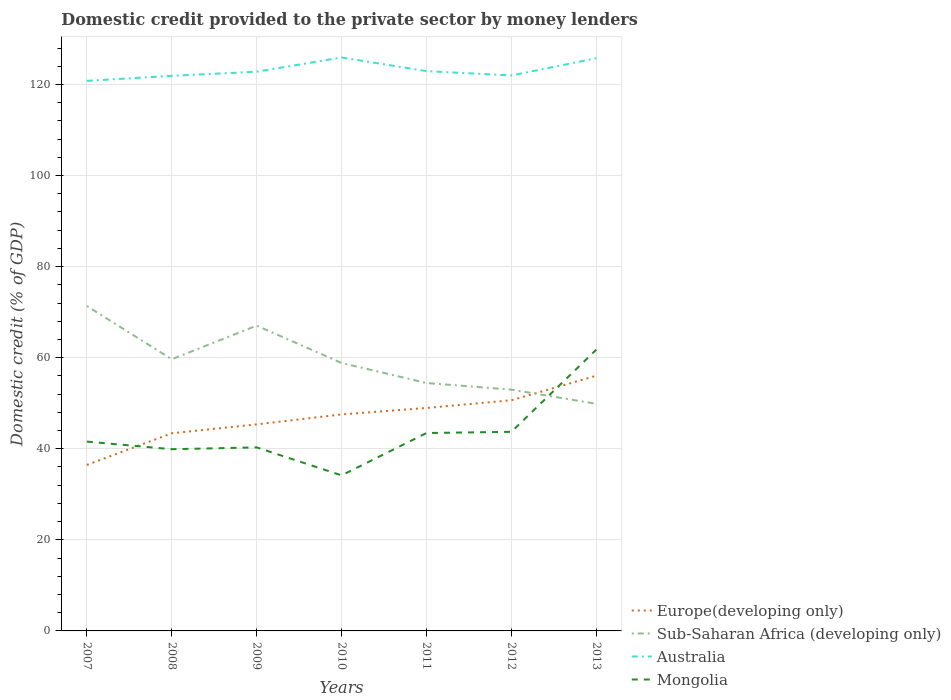Does the line corresponding to Sub-Saharan Africa (developing only) intersect with the line corresponding to Australia?
Your answer should be compact. No. Across all years, what is the maximum domestic credit provided to the private sector by money lenders in Mongolia?
Provide a succinct answer. 34.16. In which year was the domestic credit provided to the private sector by money lenders in Sub-Saharan Africa (developing only) maximum?
Your answer should be compact. 2013. What is the total domestic credit provided to the private sector by money lenders in Sub-Saharan Africa (developing only) in the graph?
Give a very brief answer. 4.31. What is the difference between the highest and the second highest domestic credit provided to the private sector by money lenders in Australia?
Keep it short and to the point. 5.13. Is the domestic credit provided to the private sector by money lenders in Mongolia strictly greater than the domestic credit provided to the private sector by money lenders in Europe(developing only) over the years?
Provide a succinct answer. No. How many years are there in the graph?
Offer a very short reply. 7. Are the values on the major ticks of Y-axis written in scientific E-notation?
Your response must be concise. No. Does the graph contain any zero values?
Provide a succinct answer. No. Does the graph contain grids?
Offer a terse response. Yes. Where does the legend appear in the graph?
Keep it short and to the point. Bottom right. How are the legend labels stacked?
Give a very brief answer. Vertical. What is the title of the graph?
Ensure brevity in your answer.  Domestic credit provided to the private sector by money lenders. Does "Georgia" appear as one of the legend labels in the graph?
Give a very brief answer. No. What is the label or title of the Y-axis?
Your answer should be very brief. Domestic credit (% of GDP). What is the Domestic credit (% of GDP) of Europe(developing only) in 2007?
Make the answer very short. 36.45. What is the Domestic credit (% of GDP) of Sub-Saharan Africa (developing only) in 2007?
Provide a short and direct response. 71.35. What is the Domestic credit (% of GDP) in Australia in 2007?
Your response must be concise. 120.79. What is the Domestic credit (% of GDP) of Mongolia in 2007?
Offer a very short reply. 41.58. What is the Domestic credit (% of GDP) of Europe(developing only) in 2008?
Your answer should be compact. 43.4. What is the Domestic credit (% of GDP) of Sub-Saharan Africa (developing only) in 2008?
Your answer should be very brief. 59.65. What is the Domestic credit (% of GDP) in Australia in 2008?
Provide a short and direct response. 121.89. What is the Domestic credit (% of GDP) of Mongolia in 2008?
Offer a terse response. 39.9. What is the Domestic credit (% of GDP) in Europe(developing only) in 2009?
Your answer should be compact. 45.36. What is the Domestic credit (% of GDP) in Sub-Saharan Africa (developing only) in 2009?
Make the answer very short. 67.04. What is the Domestic credit (% of GDP) in Australia in 2009?
Offer a terse response. 122.8. What is the Domestic credit (% of GDP) of Mongolia in 2009?
Your answer should be compact. 40.3. What is the Domestic credit (% of GDP) in Europe(developing only) in 2010?
Ensure brevity in your answer.  47.54. What is the Domestic credit (% of GDP) in Sub-Saharan Africa (developing only) in 2010?
Give a very brief answer. 58.84. What is the Domestic credit (% of GDP) of Australia in 2010?
Ensure brevity in your answer.  125.92. What is the Domestic credit (% of GDP) of Mongolia in 2010?
Offer a terse response. 34.16. What is the Domestic credit (% of GDP) of Europe(developing only) in 2011?
Give a very brief answer. 48.96. What is the Domestic credit (% of GDP) of Sub-Saharan Africa (developing only) in 2011?
Offer a terse response. 54.44. What is the Domestic credit (% of GDP) of Australia in 2011?
Your answer should be very brief. 122.93. What is the Domestic credit (% of GDP) in Mongolia in 2011?
Provide a succinct answer. 43.46. What is the Domestic credit (% of GDP) in Europe(developing only) in 2012?
Offer a very short reply. 50.66. What is the Domestic credit (% of GDP) of Sub-Saharan Africa (developing only) in 2012?
Provide a short and direct response. 52.98. What is the Domestic credit (% of GDP) in Australia in 2012?
Your answer should be very brief. 121.97. What is the Domestic credit (% of GDP) of Mongolia in 2012?
Keep it short and to the point. 43.72. What is the Domestic credit (% of GDP) of Europe(developing only) in 2013?
Your answer should be compact. 56.04. What is the Domestic credit (% of GDP) in Sub-Saharan Africa (developing only) in 2013?
Provide a short and direct response. 49.87. What is the Domestic credit (% of GDP) in Australia in 2013?
Make the answer very short. 125.76. What is the Domestic credit (% of GDP) of Mongolia in 2013?
Make the answer very short. 61.76. Across all years, what is the maximum Domestic credit (% of GDP) in Europe(developing only)?
Offer a very short reply. 56.04. Across all years, what is the maximum Domestic credit (% of GDP) of Sub-Saharan Africa (developing only)?
Your answer should be very brief. 71.35. Across all years, what is the maximum Domestic credit (% of GDP) of Australia?
Make the answer very short. 125.92. Across all years, what is the maximum Domestic credit (% of GDP) of Mongolia?
Offer a very short reply. 61.76. Across all years, what is the minimum Domestic credit (% of GDP) of Europe(developing only)?
Provide a short and direct response. 36.45. Across all years, what is the minimum Domestic credit (% of GDP) in Sub-Saharan Africa (developing only)?
Give a very brief answer. 49.87. Across all years, what is the minimum Domestic credit (% of GDP) in Australia?
Ensure brevity in your answer.  120.79. Across all years, what is the minimum Domestic credit (% of GDP) of Mongolia?
Provide a succinct answer. 34.16. What is the total Domestic credit (% of GDP) in Europe(developing only) in the graph?
Your answer should be compact. 328.4. What is the total Domestic credit (% of GDP) of Sub-Saharan Africa (developing only) in the graph?
Your response must be concise. 414.17. What is the total Domestic credit (% of GDP) in Australia in the graph?
Ensure brevity in your answer.  862.05. What is the total Domestic credit (% of GDP) in Mongolia in the graph?
Provide a short and direct response. 304.87. What is the difference between the Domestic credit (% of GDP) in Europe(developing only) in 2007 and that in 2008?
Your response must be concise. -6.94. What is the difference between the Domestic credit (% of GDP) in Sub-Saharan Africa (developing only) in 2007 and that in 2008?
Make the answer very short. 11.7. What is the difference between the Domestic credit (% of GDP) in Australia in 2007 and that in 2008?
Your answer should be compact. -1.1. What is the difference between the Domestic credit (% of GDP) of Mongolia in 2007 and that in 2008?
Offer a very short reply. 1.67. What is the difference between the Domestic credit (% of GDP) of Europe(developing only) in 2007 and that in 2009?
Provide a succinct answer. -8.9. What is the difference between the Domestic credit (% of GDP) of Sub-Saharan Africa (developing only) in 2007 and that in 2009?
Keep it short and to the point. 4.31. What is the difference between the Domestic credit (% of GDP) of Australia in 2007 and that in 2009?
Make the answer very short. -2.01. What is the difference between the Domestic credit (% of GDP) of Mongolia in 2007 and that in 2009?
Offer a very short reply. 1.28. What is the difference between the Domestic credit (% of GDP) of Europe(developing only) in 2007 and that in 2010?
Provide a short and direct response. -11.08. What is the difference between the Domestic credit (% of GDP) of Sub-Saharan Africa (developing only) in 2007 and that in 2010?
Your answer should be compact. 12.51. What is the difference between the Domestic credit (% of GDP) of Australia in 2007 and that in 2010?
Offer a terse response. -5.13. What is the difference between the Domestic credit (% of GDP) of Mongolia in 2007 and that in 2010?
Keep it short and to the point. 7.42. What is the difference between the Domestic credit (% of GDP) of Europe(developing only) in 2007 and that in 2011?
Ensure brevity in your answer.  -12.51. What is the difference between the Domestic credit (% of GDP) in Sub-Saharan Africa (developing only) in 2007 and that in 2011?
Make the answer very short. 16.91. What is the difference between the Domestic credit (% of GDP) of Australia in 2007 and that in 2011?
Ensure brevity in your answer.  -2.14. What is the difference between the Domestic credit (% of GDP) of Mongolia in 2007 and that in 2011?
Your answer should be compact. -1.88. What is the difference between the Domestic credit (% of GDP) in Europe(developing only) in 2007 and that in 2012?
Give a very brief answer. -14.2. What is the difference between the Domestic credit (% of GDP) in Sub-Saharan Africa (developing only) in 2007 and that in 2012?
Provide a short and direct response. 18.37. What is the difference between the Domestic credit (% of GDP) of Australia in 2007 and that in 2012?
Your answer should be compact. -1.18. What is the difference between the Domestic credit (% of GDP) of Mongolia in 2007 and that in 2012?
Keep it short and to the point. -2.14. What is the difference between the Domestic credit (% of GDP) in Europe(developing only) in 2007 and that in 2013?
Offer a terse response. -19.58. What is the difference between the Domestic credit (% of GDP) in Sub-Saharan Africa (developing only) in 2007 and that in 2013?
Give a very brief answer. 21.48. What is the difference between the Domestic credit (% of GDP) in Australia in 2007 and that in 2013?
Offer a very short reply. -4.97. What is the difference between the Domestic credit (% of GDP) of Mongolia in 2007 and that in 2013?
Your answer should be very brief. -20.19. What is the difference between the Domestic credit (% of GDP) of Europe(developing only) in 2008 and that in 2009?
Your answer should be very brief. -1.96. What is the difference between the Domestic credit (% of GDP) in Sub-Saharan Africa (developing only) in 2008 and that in 2009?
Keep it short and to the point. -7.39. What is the difference between the Domestic credit (% of GDP) in Australia in 2008 and that in 2009?
Your response must be concise. -0.91. What is the difference between the Domestic credit (% of GDP) in Mongolia in 2008 and that in 2009?
Your response must be concise. -0.4. What is the difference between the Domestic credit (% of GDP) of Europe(developing only) in 2008 and that in 2010?
Give a very brief answer. -4.14. What is the difference between the Domestic credit (% of GDP) of Sub-Saharan Africa (developing only) in 2008 and that in 2010?
Provide a succinct answer. 0.82. What is the difference between the Domestic credit (% of GDP) of Australia in 2008 and that in 2010?
Offer a very short reply. -4.04. What is the difference between the Domestic credit (% of GDP) of Mongolia in 2008 and that in 2010?
Your answer should be very brief. 5.75. What is the difference between the Domestic credit (% of GDP) of Europe(developing only) in 2008 and that in 2011?
Your answer should be very brief. -5.57. What is the difference between the Domestic credit (% of GDP) in Sub-Saharan Africa (developing only) in 2008 and that in 2011?
Make the answer very short. 5.22. What is the difference between the Domestic credit (% of GDP) of Australia in 2008 and that in 2011?
Offer a terse response. -1.04. What is the difference between the Domestic credit (% of GDP) of Mongolia in 2008 and that in 2011?
Provide a short and direct response. -3.56. What is the difference between the Domestic credit (% of GDP) of Europe(developing only) in 2008 and that in 2012?
Ensure brevity in your answer.  -7.26. What is the difference between the Domestic credit (% of GDP) in Sub-Saharan Africa (developing only) in 2008 and that in 2012?
Your answer should be very brief. 6.67. What is the difference between the Domestic credit (% of GDP) of Australia in 2008 and that in 2012?
Provide a short and direct response. -0.08. What is the difference between the Domestic credit (% of GDP) of Mongolia in 2008 and that in 2012?
Provide a short and direct response. -3.82. What is the difference between the Domestic credit (% of GDP) of Europe(developing only) in 2008 and that in 2013?
Offer a very short reply. -12.64. What is the difference between the Domestic credit (% of GDP) in Sub-Saharan Africa (developing only) in 2008 and that in 2013?
Your answer should be very brief. 9.78. What is the difference between the Domestic credit (% of GDP) in Australia in 2008 and that in 2013?
Make the answer very short. -3.87. What is the difference between the Domestic credit (% of GDP) in Mongolia in 2008 and that in 2013?
Provide a succinct answer. -21.86. What is the difference between the Domestic credit (% of GDP) of Europe(developing only) in 2009 and that in 2010?
Provide a short and direct response. -2.18. What is the difference between the Domestic credit (% of GDP) of Sub-Saharan Africa (developing only) in 2009 and that in 2010?
Your answer should be very brief. 8.2. What is the difference between the Domestic credit (% of GDP) in Australia in 2009 and that in 2010?
Make the answer very short. -3.13. What is the difference between the Domestic credit (% of GDP) of Mongolia in 2009 and that in 2010?
Your answer should be very brief. 6.14. What is the difference between the Domestic credit (% of GDP) in Europe(developing only) in 2009 and that in 2011?
Make the answer very short. -3.6. What is the difference between the Domestic credit (% of GDP) of Sub-Saharan Africa (developing only) in 2009 and that in 2011?
Your answer should be very brief. 12.6. What is the difference between the Domestic credit (% of GDP) of Australia in 2009 and that in 2011?
Keep it short and to the point. -0.13. What is the difference between the Domestic credit (% of GDP) in Mongolia in 2009 and that in 2011?
Keep it short and to the point. -3.16. What is the difference between the Domestic credit (% of GDP) of Europe(developing only) in 2009 and that in 2012?
Keep it short and to the point. -5.3. What is the difference between the Domestic credit (% of GDP) in Sub-Saharan Africa (developing only) in 2009 and that in 2012?
Your answer should be compact. 14.06. What is the difference between the Domestic credit (% of GDP) in Australia in 2009 and that in 2012?
Ensure brevity in your answer.  0.83. What is the difference between the Domestic credit (% of GDP) in Mongolia in 2009 and that in 2012?
Make the answer very short. -3.42. What is the difference between the Domestic credit (% of GDP) in Europe(developing only) in 2009 and that in 2013?
Ensure brevity in your answer.  -10.68. What is the difference between the Domestic credit (% of GDP) in Sub-Saharan Africa (developing only) in 2009 and that in 2013?
Make the answer very short. 17.17. What is the difference between the Domestic credit (% of GDP) of Australia in 2009 and that in 2013?
Provide a succinct answer. -2.96. What is the difference between the Domestic credit (% of GDP) in Mongolia in 2009 and that in 2013?
Give a very brief answer. -21.46. What is the difference between the Domestic credit (% of GDP) of Europe(developing only) in 2010 and that in 2011?
Your answer should be very brief. -1.42. What is the difference between the Domestic credit (% of GDP) in Sub-Saharan Africa (developing only) in 2010 and that in 2011?
Keep it short and to the point. 4.4. What is the difference between the Domestic credit (% of GDP) of Australia in 2010 and that in 2011?
Your answer should be very brief. 3. What is the difference between the Domestic credit (% of GDP) in Mongolia in 2010 and that in 2011?
Offer a very short reply. -9.3. What is the difference between the Domestic credit (% of GDP) of Europe(developing only) in 2010 and that in 2012?
Your answer should be very brief. -3.12. What is the difference between the Domestic credit (% of GDP) in Sub-Saharan Africa (developing only) in 2010 and that in 2012?
Your answer should be very brief. 5.86. What is the difference between the Domestic credit (% of GDP) of Australia in 2010 and that in 2012?
Keep it short and to the point. 3.95. What is the difference between the Domestic credit (% of GDP) in Mongolia in 2010 and that in 2012?
Keep it short and to the point. -9.56. What is the difference between the Domestic credit (% of GDP) in Europe(developing only) in 2010 and that in 2013?
Provide a succinct answer. -8.5. What is the difference between the Domestic credit (% of GDP) in Sub-Saharan Africa (developing only) in 2010 and that in 2013?
Your answer should be compact. 8.97. What is the difference between the Domestic credit (% of GDP) of Australia in 2010 and that in 2013?
Offer a terse response. 0.16. What is the difference between the Domestic credit (% of GDP) in Mongolia in 2010 and that in 2013?
Your answer should be compact. -27.61. What is the difference between the Domestic credit (% of GDP) of Europe(developing only) in 2011 and that in 2012?
Provide a short and direct response. -1.69. What is the difference between the Domestic credit (% of GDP) in Sub-Saharan Africa (developing only) in 2011 and that in 2012?
Your response must be concise. 1.46. What is the difference between the Domestic credit (% of GDP) in Australia in 2011 and that in 2012?
Offer a very short reply. 0.96. What is the difference between the Domestic credit (% of GDP) of Mongolia in 2011 and that in 2012?
Provide a succinct answer. -0.26. What is the difference between the Domestic credit (% of GDP) of Europe(developing only) in 2011 and that in 2013?
Ensure brevity in your answer.  -7.08. What is the difference between the Domestic credit (% of GDP) in Sub-Saharan Africa (developing only) in 2011 and that in 2013?
Ensure brevity in your answer.  4.57. What is the difference between the Domestic credit (% of GDP) of Australia in 2011 and that in 2013?
Your answer should be compact. -2.83. What is the difference between the Domestic credit (% of GDP) in Mongolia in 2011 and that in 2013?
Offer a terse response. -18.3. What is the difference between the Domestic credit (% of GDP) in Europe(developing only) in 2012 and that in 2013?
Make the answer very short. -5.38. What is the difference between the Domestic credit (% of GDP) of Sub-Saharan Africa (developing only) in 2012 and that in 2013?
Give a very brief answer. 3.11. What is the difference between the Domestic credit (% of GDP) in Australia in 2012 and that in 2013?
Provide a succinct answer. -3.79. What is the difference between the Domestic credit (% of GDP) of Mongolia in 2012 and that in 2013?
Your response must be concise. -18.05. What is the difference between the Domestic credit (% of GDP) in Europe(developing only) in 2007 and the Domestic credit (% of GDP) in Sub-Saharan Africa (developing only) in 2008?
Your response must be concise. -23.2. What is the difference between the Domestic credit (% of GDP) of Europe(developing only) in 2007 and the Domestic credit (% of GDP) of Australia in 2008?
Give a very brief answer. -85.43. What is the difference between the Domestic credit (% of GDP) of Europe(developing only) in 2007 and the Domestic credit (% of GDP) of Mongolia in 2008?
Your answer should be compact. -3.45. What is the difference between the Domestic credit (% of GDP) in Sub-Saharan Africa (developing only) in 2007 and the Domestic credit (% of GDP) in Australia in 2008?
Give a very brief answer. -50.54. What is the difference between the Domestic credit (% of GDP) of Sub-Saharan Africa (developing only) in 2007 and the Domestic credit (% of GDP) of Mongolia in 2008?
Your answer should be very brief. 31.45. What is the difference between the Domestic credit (% of GDP) of Australia in 2007 and the Domestic credit (% of GDP) of Mongolia in 2008?
Offer a terse response. 80.89. What is the difference between the Domestic credit (% of GDP) of Europe(developing only) in 2007 and the Domestic credit (% of GDP) of Sub-Saharan Africa (developing only) in 2009?
Provide a short and direct response. -30.58. What is the difference between the Domestic credit (% of GDP) of Europe(developing only) in 2007 and the Domestic credit (% of GDP) of Australia in 2009?
Your response must be concise. -86.34. What is the difference between the Domestic credit (% of GDP) of Europe(developing only) in 2007 and the Domestic credit (% of GDP) of Mongolia in 2009?
Give a very brief answer. -3.85. What is the difference between the Domestic credit (% of GDP) in Sub-Saharan Africa (developing only) in 2007 and the Domestic credit (% of GDP) in Australia in 2009?
Your answer should be very brief. -51.45. What is the difference between the Domestic credit (% of GDP) in Sub-Saharan Africa (developing only) in 2007 and the Domestic credit (% of GDP) in Mongolia in 2009?
Your answer should be very brief. 31.05. What is the difference between the Domestic credit (% of GDP) of Australia in 2007 and the Domestic credit (% of GDP) of Mongolia in 2009?
Provide a short and direct response. 80.49. What is the difference between the Domestic credit (% of GDP) in Europe(developing only) in 2007 and the Domestic credit (% of GDP) in Sub-Saharan Africa (developing only) in 2010?
Offer a very short reply. -22.38. What is the difference between the Domestic credit (% of GDP) of Europe(developing only) in 2007 and the Domestic credit (% of GDP) of Australia in 2010?
Give a very brief answer. -89.47. What is the difference between the Domestic credit (% of GDP) of Europe(developing only) in 2007 and the Domestic credit (% of GDP) of Mongolia in 2010?
Give a very brief answer. 2.3. What is the difference between the Domestic credit (% of GDP) of Sub-Saharan Africa (developing only) in 2007 and the Domestic credit (% of GDP) of Australia in 2010?
Keep it short and to the point. -54.57. What is the difference between the Domestic credit (% of GDP) in Sub-Saharan Africa (developing only) in 2007 and the Domestic credit (% of GDP) in Mongolia in 2010?
Give a very brief answer. 37.19. What is the difference between the Domestic credit (% of GDP) of Australia in 2007 and the Domestic credit (% of GDP) of Mongolia in 2010?
Your answer should be compact. 86.63. What is the difference between the Domestic credit (% of GDP) of Europe(developing only) in 2007 and the Domestic credit (% of GDP) of Sub-Saharan Africa (developing only) in 2011?
Offer a terse response. -17.98. What is the difference between the Domestic credit (% of GDP) in Europe(developing only) in 2007 and the Domestic credit (% of GDP) in Australia in 2011?
Your answer should be compact. -86.47. What is the difference between the Domestic credit (% of GDP) of Europe(developing only) in 2007 and the Domestic credit (% of GDP) of Mongolia in 2011?
Make the answer very short. -7. What is the difference between the Domestic credit (% of GDP) in Sub-Saharan Africa (developing only) in 2007 and the Domestic credit (% of GDP) in Australia in 2011?
Give a very brief answer. -51.58. What is the difference between the Domestic credit (% of GDP) in Sub-Saharan Africa (developing only) in 2007 and the Domestic credit (% of GDP) in Mongolia in 2011?
Offer a very short reply. 27.89. What is the difference between the Domestic credit (% of GDP) in Australia in 2007 and the Domestic credit (% of GDP) in Mongolia in 2011?
Keep it short and to the point. 77.33. What is the difference between the Domestic credit (% of GDP) in Europe(developing only) in 2007 and the Domestic credit (% of GDP) in Sub-Saharan Africa (developing only) in 2012?
Provide a succinct answer. -16.52. What is the difference between the Domestic credit (% of GDP) in Europe(developing only) in 2007 and the Domestic credit (% of GDP) in Australia in 2012?
Keep it short and to the point. -85.51. What is the difference between the Domestic credit (% of GDP) in Europe(developing only) in 2007 and the Domestic credit (% of GDP) in Mongolia in 2012?
Your response must be concise. -7.26. What is the difference between the Domestic credit (% of GDP) in Sub-Saharan Africa (developing only) in 2007 and the Domestic credit (% of GDP) in Australia in 2012?
Your response must be concise. -50.62. What is the difference between the Domestic credit (% of GDP) of Sub-Saharan Africa (developing only) in 2007 and the Domestic credit (% of GDP) of Mongolia in 2012?
Give a very brief answer. 27.63. What is the difference between the Domestic credit (% of GDP) of Australia in 2007 and the Domestic credit (% of GDP) of Mongolia in 2012?
Your answer should be compact. 77.07. What is the difference between the Domestic credit (% of GDP) of Europe(developing only) in 2007 and the Domestic credit (% of GDP) of Sub-Saharan Africa (developing only) in 2013?
Provide a succinct answer. -13.42. What is the difference between the Domestic credit (% of GDP) of Europe(developing only) in 2007 and the Domestic credit (% of GDP) of Australia in 2013?
Keep it short and to the point. -89.3. What is the difference between the Domestic credit (% of GDP) in Europe(developing only) in 2007 and the Domestic credit (% of GDP) in Mongolia in 2013?
Ensure brevity in your answer.  -25.31. What is the difference between the Domestic credit (% of GDP) in Sub-Saharan Africa (developing only) in 2007 and the Domestic credit (% of GDP) in Australia in 2013?
Provide a succinct answer. -54.41. What is the difference between the Domestic credit (% of GDP) of Sub-Saharan Africa (developing only) in 2007 and the Domestic credit (% of GDP) of Mongolia in 2013?
Ensure brevity in your answer.  9.59. What is the difference between the Domestic credit (% of GDP) of Australia in 2007 and the Domestic credit (% of GDP) of Mongolia in 2013?
Give a very brief answer. 59.02. What is the difference between the Domestic credit (% of GDP) in Europe(developing only) in 2008 and the Domestic credit (% of GDP) in Sub-Saharan Africa (developing only) in 2009?
Provide a short and direct response. -23.64. What is the difference between the Domestic credit (% of GDP) of Europe(developing only) in 2008 and the Domestic credit (% of GDP) of Australia in 2009?
Keep it short and to the point. -79.4. What is the difference between the Domestic credit (% of GDP) of Europe(developing only) in 2008 and the Domestic credit (% of GDP) of Mongolia in 2009?
Make the answer very short. 3.1. What is the difference between the Domestic credit (% of GDP) in Sub-Saharan Africa (developing only) in 2008 and the Domestic credit (% of GDP) in Australia in 2009?
Ensure brevity in your answer.  -63.14. What is the difference between the Domestic credit (% of GDP) of Sub-Saharan Africa (developing only) in 2008 and the Domestic credit (% of GDP) of Mongolia in 2009?
Offer a terse response. 19.35. What is the difference between the Domestic credit (% of GDP) in Australia in 2008 and the Domestic credit (% of GDP) in Mongolia in 2009?
Your answer should be compact. 81.59. What is the difference between the Domestic credit (% of GDP) in Europe(developing only) in 2008 and the Domestic credit (% of GDP) in Sub-Saharan Africa (developing only) in 2010?
Your response must be concise. -15.44. What is the difference between the Domestic credit (% of GDP) of Europe(developing only) in 2008 and the Domestic credit (% of GDP) of Australia in 2010?
Make the answer very short. -82.53. What is the difference between the Domestic credit (% of GDP) of Europe(developing only) in 2008 and the Domestic credit (% of GDP) of Mongolia in 2010?
Ensure brevity in your answer.  9.24. What is the difference between the Domestic credit (% of GDP) of Sub-Saharan Africa (developing only) in 2008 and the Domestic credit (% of GDP) of Australia in 2010?
Provide a succinct answer. -66.27. What is the difference between the Domestic credit (% of GDP) of Sub-Saharan Africa (developing only) in 2008 and the Domestic credit (% of GDP) of Mongolia in 2010?
Provide a succinct answer. 25.5. What is the difference between the Domestic credit (% of GDP) in Australia in 2008 and the Domestic credit (% of GDP) in Mongolia in 2010?
Your response must be concise. 87.73. What is the difference between the Domestic credit (% of GDP) of Europe(developing only) in 2008 and the Domestic credit (% of GDP) of Sub-Saharan Africa (developing only) in 2011?
Your answer should be very brief. -11.04. What is the difference between the Domestic credit (% of GDP) of Europe(developing only) in 2008 and the Domestic credit (% of GDP) of Australia in 2011?
Provide a succinct answer. -79.53. What is the difference between the Domestic credit (% of GDP) of Europe(developing only) in 2008 and the Domestic credit (% of GDP) of Mongolia in 2011?
Provide a succinct answer. -0.06. What is the difference between the Domestic credit (% of GDP) in Sub-Saharan Africa (developing only) in 2008 and the Domestic credit (% of GDP) in Australia in 2011?
Keep it short and to the point. -63.27. What is the difference between the Domestic credit (% of GDP) of Sub-Saharan Africa (developing only) in 2008 and the Domestic credit (% of GDP) of Mongolia in 2011?
Your answer should be very brief. 16.19. What is the difference between the Domestic credit (% of GDP) of Australia in 2008 and the Domestic credit (% of GDP) of Mongolia in 2011?
Your answer should be very brief. 78.43. What is the difference between the Domestic credit (% of GDP) of Europe(developing only) in 2008 and the Domestic credit (% of GDP) of Sub-Saharan Africa (developing only) in 2012?
Offer a very short reply. -9.58. What is the difference between the Domestic credit (% of GDP) in Europe(developing only) in 2008 and the Domestic credit (% of GDP) in Australia in 2012?
Provide a short and direct response. -78.57. What is the difference between the Domestic credit (% of GDP) in Europe(developing only) in 2008 and the Domestic credit (% of GDP) in Mongolia in 2012?
Offer a terse response. -0.32. What is the difference between the Domestic credit (% of GDP) of Sub-Saharan Africa (developing only) in 2008 and the Domestic credit (% of GDP) of Australia in 2012?
Provide a short and direct response. -62.31. What is the difference between the Domestic credit (% of GDP) of Sub-Saharan Africa (developing only) in 2008 and the Domestic credit (% of GDP) of Mongolia in 2012?
Your answer should be compact. 15.94. What is the difference between the Domestic credit (% of GDP) in Australia in 2008 and the Domestic credit (% of GDP) in Mongolia in 2012?
Your answer should be compact. 78.17. What is the difference between the Domestic credit (% of GDP) in Europe(developing only) in 2008 and the Domestic credit (% of GDP) in Sub-Saharan Africa (developing only) in 2013?
Give a very brief answer. -6.48. What is the difference between the Domestic credit (% of GDP) of Europe(developing only) in 2008 and the Domestic credit (% of GDP) of Australia in 2013?
Make the answer very short. -82.36. What is the difference between the Domestic credit (% of GDP) in Europe(developing only) in 2008 and the Domestic credit (% of GDP) in Mongolia in 2013?
Offer a terse response. -18.37. What is the difference between the Domestic credit (% of GDP) of Sub-Saharan Africa (developing only) in 2008 and the Domestic credit (% of GDP) of Australia in 2013?
Make the answer very short. -66.1. What is the difference between the Domestic credit (% of GDP) in Sub-Saharan Africa (developing only) in 2008 and the Domestic credit (% of GDP) in Mongolia in 2013?
Your response must be concise. -2.11. What is the difference between the Domestic credit (% of GDP) of Australia in 2008 and the Domestic credit (% of GDP) of Mongolia in 2013?
Your response must be concise. 60.12. What is the difference between the Domestic credit (% of GDP) of Europe(developing only) in 2009 and the Domestic credit (% of GDP) of Sub-Saharan Africa (developing only) in 2010?
Offer a terse response. -13.48. What is the difference between the Domestic credit (% of GDP) in Europe(developing only) in 2009 and the Domestic credit (% of GDP) in Australia in 2010?
Offer a very short reply. -80.57. What is the difference between the Domestic credit (% of GDP) of Europe(developing only) in 2009 and the Domestic credit (% of GDP) of Mongolia in 2010?
Make the answer very short. 11.2. What is the difference between the Domestic credit (% of GDP) of Sub-Saharan Africa (developing only) in 2009 and the Domestic credit (% of GDP) of Australia in 2010?
Make the answer very short. -58.88. What is the difference between the Domestic credit (% of GDP) of Sub-Saharan Africa (developing only) in 2009 and the Domestic credit (% of GDP) of Mongolia in 2010?
Offer a very short reply. 32.88. What is the difference between the Domestic credit (% of GDP) of Australia in 2009 and the Domestic credit (% of GDP) of Mongolia in 2010?
Provide a short and direct response. 88.64. What is the difference between the Domestic credit (% of GDP) of Europe(developing only) in 2009 and the Domestic credit (% of GDP) of Sub-Saharan Africa (developing only) in 2011?
Your answer should be very brief. -9.08. What is the difference between the Domestic credit (% of GDP) of Europe(developing only) in 2009 and the Domestic credit (% of GDP) of Australia in 2011?
Offer a terse response. -77.57. What is the difference between the Domestic credit (% of GDP) of Europe(developing only) in 2009 and the Domestic credit (% of GDP) of Mongolia in 2011?
Ensure brevity in your answer.  1.9. What is the difference between the Domestic credit (% of GDP) in Sub-Saharan Africa (developing only) in 2009 and the Domestic credit (% of GDP) in Australia in 2011?
Your answer should be very brief. -55.89. What is the difference between the Domestic credit (% of GDP) of Sub-Saharan Africa (developing only) in 2009 and the Domestic credit (% of GDP) of Mongolia in 2011?
Offer a very short reply. 23.58. What is the difference between the Domestic credit (% of GDP) of Australia in 2009 and the Domestic credit (% of GDP) of Mongolia in 2011?
Provide a short and direct response. 79.34. What is the difference between the Domestic credit (% of GDP) in Europe(developing only) in 2009 and the Domestic credit (% of GDP) in Sub-Saharan Africa (developing only) in 2012?
Your answer should be very brief. -7.62. What is the difference between the Domestic credit (% of GDP) of Europe(developing only) in 2009 and the Domestic credit (% of GDP) of Australia in 2012?
Your answer should be very brief. -76.61. What is the difference between the Domestic credit (% of GDP) in Europe(developing only) in 2009 and the Domestic credit (% of GDP) in Mongolia in 2012?
Your response must be concise. 1.64. What is the difference between the Domestic credit (% of GDP) of Sub-Saharan Africa (developing only) in 2009 and the Domestic credit (% of GDP) of Australia in 2012?
Your response must be concise. -54.93. What is the difference between the Domestic credit (% of GDP) of Sub-Saharan Africa (developing only) in 2009 and the Domestic credit (% of GDP) of Mongolia in 2012?
Provide a succinct answer. 23.32. What is the difference between the Domestic credit (% of GDP) of Australia in 2009 and the Domestic credit (% of GDP) of Mongolia in 2012?
Your answer should be compact. 79.08. What is the difference between the Domestic credit (% of GDP) in Europe(developing only) in 2009 and the Domestic credit (% of GDP) in Sub-Saharan Africa (developing only) in 2013?
Offer a terse response. -4.51. What is the difference between the Domestic credit (% of GDP) in Europe(developing only) in 2009 and the Domestic credit (% of GDP) in Australia in 2013?
Give a very brief answer. -80.4. What is the difference between the Domestic credit (% of GDP) in Europe(developing only) in 2009 and the Domestic credit (% of GDP) in Mongolia in 2013?
Make the answer very short. -16.41. What is the difference between the Domestic credit (% of GDP) in Sub-Saharan Africa (developing only) in 2009 and the Domestic credit (% of GDP) in Australia in 2013?
Offer a very short reply. -58.72. What is the difference between the Domestic credit (% of GDP) in Sub-Saharan Africa (developing only) in 2009 and the Domestic credit (% of GDP) in Mongolia in 2013?
Offer a terse response. 5.28. What is the difference between the Domestic credit (% of GDP) in Australia in 2009 and the Domestic credit (% of GDP) in Mongolia in 2013?
Keep it short and to the point. 61.03. What is the difference between the Domestic credit (% of GDP) in Europe(developing only) in 2010 and the Domestic credit (% of GDP) in Sub-Saharan Africa (developing only) in 2011?
Your answer should be compact. -6.9. What is the difference between the Domestic credit (% of GDP) in Europe(developing only) in 2010 and the Domestic credit (% of GDP) in Australia in 2011?
Your answer should be compact. -75.39. What is the difference between the Domestic credit (% of GDP) of Europe(developing only) in 2010 and the Domestic credit (% of GDP) of Mongolia in 2011?
Your response must be concise. 4.08. What is the difference between the Domestic credit (% of GDP) in Sub-Saharan Africa (developing only) in 2010 and the Domestic credit (% of GDP) in Australia in 2011?
Ensure brevity in your answer.  -64.09. What is the difference between the Domestic credit (% of GDP) in Sub-Saharan Africa (developing only) in 2010 and the Domestic credit (% of GDP) in Mongolia in 2011?
Offer a terse response. 15.38. What is the difference between the Domestic credit (% of GDP) in Australia in 2010 and the Domestic credit (% of GDP) in Mongolia in 2011?
Make the answer very short. 82.46. What is the difference between the Domestic credit (% of GDP) of Europe(developing only) in 2010 and the Domestic credit (% of GDP) of Sub-Saharan Africa (developing only) in 2012?
Keep it short and to the point. -5.44. What is the difference between the Domestic credit (% of GDP) of Europe(developing only) in 2010 and the Domestic credit (% of GDP) of Australia in 2012?
Your response must be concise. -74.43. What is the difference between the Domestic credit (% of GDP) in Europe(developing only) in 2010 and the Domestic credit (% of GDP) in Mongolia in 2012?
Your answer should be very brief. 3.82. What is the difference between the Domestic credit (% of GDP) of Sub-Saharan Africa (developing only) in 2010 and the Domestic credit (% of GDP) of Australia in 2012?
Offer a very short reply. -63.13. What is the difference between the Domestic credit (% of GDP) of Sub-Saharan Africa (developing only) in 2010 and the Domestic credit (% of GDP) of Mongolia in 2012?
Give a very brief answer. 15.12. What is the difference between the Domestic credit (% of GDP) in Australia in 2010 and the Domestic credit (% of GDP) in Mongolia in 2012?
Make the answer very short. 82.21. What is the difference between the Domestic credit (% of GDP) in Europe(developing only) in 2010 and the Domestic credit (% of GDP) in Sub-Saharan Africa (developing only) in 2013?
Make the answer very short. -2.33. What is the difference between the Domestic credit (% of GDP) of Europe(developing only) in 2010 and the Domestic credit (% of GDP) of Australia in 2013?
Your response must be concise. -78.22. What is the difference between the Domestic credit (% of GDP) in Europe(developing only) in 2010 and the Domestic credit (% of GDP) in Mongolia in 2013?
Offer a terse response. -14.23. What is the difference between the Domestic credit (% of GDP) in Sub-Saharan Africa (developing only) in 2010 and the Domestic credit (% of GDP) in Australia in 2013?
Provide a short and direct response. -66.92. What is the difference between the Domestic credit (% of GDP) in Sub-Saharan Africa (developing only) in 2010 and the Domestic credit (% of GDP) in Mongolia in 2013?
Your answer should be compact. -2.93. What is the difference between the Domestic credit (% of GDP) of Australia in 2010 and the Domestic credit (% of GDP) of Mongolia in 2013?
Give a very brief answer. 64.16. What is the difference between the Domestic credit (% of GDP) in Europe(developing only) in 2011 and the Domestic credit (% of GDP) in Sub-Saharan Africa (developing only) in 2012?
Keep it short and to the point. -4.02. What is the difference between the Domestic credit (% of GDP) of Europe(developing only) in 2011 and the Domestic credit (% of GDP) of Australia in 2012?
Give a very brief answer. -73.01. What is the difference between the Domestic credit (% of GDP) of Europe(developing only) in 2011 and the Domestic credit (% of GDP) of Mongolia in 2012?
Keep it short and to the point. 5.25. What is the difference between the Domestic credit (% of GDP) of Sub-Saharan Africa (developing only) in 2011 and the Domestic credit (% of GDP) of Australia in 2012?
Ensure brevity in your answer.  -67.53. What is the difference between the Domestic credit (% of GDP) of Sub-Saharan Africa (developing only) in 2011 and the Domestic credit (% of GDP) of Mongolia in 2012?
Keep it short and to the point. 10.72. What is the difference between the Domestic credit (% of GDP) of Australia in 2011 and the Domestic credit (% of GDP) of Mongolia in 2012?
Make the answer very short. 79.21. What is the difference between the Domestic credit (% of GDP) of Europe(developing only) in 2011 and the Domestic credit (% of GDP) of Sub-Saharan Africa (developing only) in 2013?
Offer a terse response. -0.91. What is the difference between the Domestic credit (% of GDP) in Europe(developing only) in 2011 and the Domestic credit (% of GDP) in Australia in 2013?
Provide a succinct answer. -76.8. What is the difference between the Domestic credit (% of GDP) in Europe(developing only) in 2011 and the Domestic credit (% of GDP) in Mongolia in 2013?
Ensure brevity in your answer.  -12.8. What is the difference between the Domestic credit (% of GDP) of Sub-Saharan Africa (developing only) in 2011 and the Domestic credit (% of GDP) of Australia in 2013?
Your answer should be compact. -71.32. What is the difference between the Domestic credit (% of GDP) of Sub-Saharan Africa (developing only) in 2011 and the Domestic credit (% of GDP) of Mongolia in 2013?
Your answer should be very brief. -7.33. What is the difference between the Domestic credit (% of GDP) of Australia in 2011 and the Domestic credit (% of GDP) of Mongolia in 2013?
Your answer should be very brief. 61.16. What is the difference between the Domestic credit (% of GDP) in Europe(developing only) in 2012 and the Domestic credit (% of GDP) in Sub-Saharan Africa (developing only) in 2013?
Offer a very short reply. 0.78. What is the difference between the Domestic credit (% of GDP) in Europe(developing only) in 2012 and the Domestic credit (% of GDP) in Australia in 2013?
Provide a succinct answer. -75.1. What is the difference between the Domestic credit (% of GDP) in Europe(developing only) in 2012 and the Domestic credit (% of GDP) in Mongolia in 2013?
Offer a terse response. -11.11. What is the difference between the Domestic credit (% of GDP) of Sub-Saharan Africa (developing only) in 2012 and the Domestic credit (% of GDP) of Australia in 2013?
Offer a very short reply. -72.78. What is the difference between the Domestic credit (% of GDP) in Sub-Saharan Africa (developing only) in 2012 and the Domestic credit (% of GDP) in Mongolia in 2013?
Offer a terse response. -8.78. What is the difference between the Domestic credit (% of GDP) of Australia in 2012 and the Domestic credit (% of GDP) of Mongolia in 2013?
Provide a succinct answer. 60.2. What is the average Domestic credit (% of GDP) of Europe(developing only) per year?
Provide a succinct answer. 46.91. What is the average Domestic credit (% of GDP) of Sub-Saharan Africa (developing only) per year?
Your response must be concise. 59.17. What is the average Domestic credit (% of GDP) of Australia per year?
Offer a terse response. 123.15. What is the average Domestic credit (% of GDP) of Mongolia per year?
Provide a succinct answer. 43.55. In the year 2007, what is the difference between the Domestic credit (% of GDP) in Europe(developing only) and Domestic credit (% of GDP) in Sub-Saharan Africa (developing only)?
Offer a terse response. -34.9. In the year 2007, what is the difference between the Domestic credit (% of GDP) in Europe(developing only) and Domestic credit (% of GDP) in Australia?
Provide a short and direct response. -84.33. In the year 2007, what is the difference between the Domestic credit (% of GDP) of Europe(developing only) and Domestic credit (% of GDP) of Mongolia?
Your response must be concise. -5.12. In the year 2007, what is the difference between the Domestic credit (% of GDP) of Sub-Saharan Africa (developing only) and Domestic credit (% of GDP) of Australia?
Provide a succinct answer. -49.44. In the year 2007, what is the difference between the Domestic credit (% of GDP) of Sub-Saharan Africa (developing only) and Domestic credit (% of GDP) of Mongolia?
Provide a short and direct response. 29.77. In the year 2007, what is the difference between the Domestic credit (% of GDP) of Australia and Domestic credit (% of GDP) of Mongolia?
Your answer should be compact. 79.21. In the year 2008, what is the difference between the Domestic credit (% of GDP) in Europe(developing only) and Domestic credit (% of GDP) in Sub-Saharan Africa (developing only)?
Provide a succinct answer. -16.26. In the year 2008, what is the difference between the Domestic credit (% of GDP) in Europe(developing only) and Domestic credit (% of GDP) in Australia?
Your answer should be very brief. -78.49. In the year 2008, what is the difference between the Domestic credit (% of GDP) of Europe(developing only) and Domestic credit (% of GDP) of Mongolia?
Offer a terse response. 3.49. In the year 2008, what is the difference between the Domestic credit (% of GDP) of Sub-Saharan Africa (developing only) and Domestic credit (% of GDP) of Australia?
Keep it short and to the point. -62.23. In the year 2008, what is the difference between the Domestic credit (% of GDP) of Sub-Saharan Africa (developing only) and Domestic credit (% of GDP) of Mongolia?
Your answer should be compact. 19.75. In the year 2008, what is the difference between the Domestic credit (% of GDP) in Australia and Domestic credit (% of GDP) in Mongolia?
Keep it short and to the point. 81.99. In the year 2009, what is the difference between the Domestic credit (% of GDP) in Europe(developing only) and Domestic credit (% of GDP) in Sub-Saharan Africa (developing only)?
Provide a succinct answer. -21.68. In the year 2009, what is the difference between the Domestic credit (% of GDP) of Europe(developing only) and Domestic credit (% of GDP) of Australia?
Offer a very short reply. -77.44. In the year 2009, what is the difference between the Domestic credit (% of GDP) in Europe(developing only) and Domestic credit (% of GDP) in Mongolia?
Make the answer very short. 5.06. In the year 2009, what is the difference between the Domestic credit (% of GDP) in Sub-Saharan Africa (developing only) and Domestic credit (% of GDP) in Australia?
Provide a succinct answer. -55.76. In the year 2009, what is the difference between the Domestic credit (% of GDP) of Sub-Saharan Africa (developing only) and Domestic credit (% of GDP) of Mongolia?
Offer a very short reply. 26.74. In the year 2009, what is the difference between the Domestic credit (% of GDP) of Australia and Domestic credit (% of GDP) of Mongolia?
Provide a short and direct response. 82.5. In the year 2010, what is the difference between the Domestic credit (% of GDP) of Europe(developing only) and Domestic credit (% of GDP) of Sub-Saharan Africa (developing only)?
Provide a succinct answer. -11.3. In the year 2010, what is the difference between the Domestic credit (% of GDP) of Europe(developing only) and Domestic credit (% of GDP) of Australia?
Provide a succinct answer. -78.38. In the year 2010, what is the difference between the Domestic credit (% of GDP) of Europe(developing only) and Domestic credit (% of GDP) of Mongolia?
Provide a short and direct response. 13.38. In the year 2010, what is the difference between the Domestic credit (% of GDP) of Sub-Saharan Africa (developing only) and Domestic credit (% of GDP) of Australia?
Give a very brief answer. -67.09. In the year 2010, what is the difference between the Domestic credit (% of GDP) of Sub-Saharan Africa (developing only) and Domestic credit (% of GDP) of Mongolia?
Ensure brevity in your answer.  24.68. In the year 2010, what is the difference between the Domestic credit (% of GDP) in Australia and Domestic credit (% of GDP) in Mongolia?
Your answer should be very brief. 91.77. In the year 2011, what is the difference between the Domestic credit (% of GDP) in Europe(developing only) and Domestic credit (% of GDP) in Sub-Saharan Africa (developing only)?
Your answer should be compact. -5.48. In the year 2011, what is the difference between the Domestic credit (% of GDP) of Europe(developing only) and Domestic credit (% of GDP) of Australia?
Your answer should be compact. -73.97. In the year 2011, what is the difference between the Domestic credit (% of GDP) of Europe(developing only) and Domestic credit (% of GDP) of Mongolia?
Your answer should be very brief. 5.5. In the year 2011, what is the difference between the Domestic credit (% of GDP) in Sub-Saharan Africa (developing only) and Domestic credit (% of GDP) in Australia?
Keep it short and to the point. -68.49. In the year 2011, what is the difference between the Domestic credit (% of GDP) in Sub-Saharan Africa (developing only) and Domestic credit (% of GDP) in Mongolia?
Provide a succinct answer. 10.98. In the year 2011, what is the difference between the Domestic credit (% of GDP) in Australia and Domestic credit (% of GDP) in Mongolia?
Your answer should be compact. 79.47. In the year 2012, what is the difference between the Domestic credit (% of GDP) of Europe(developing only) and Domestic credit (% of GDP) of Sub-Saharan Africa (developing only)?
Your response must be concise. -2.32. In the year 2012, what is the difference between the Domestic credit (% of GDP) of Europe(developing only) and Domestic credit (% of GDP) of Australia?
Your answer should be very brief. -71.31. In the year 2012, what is the difference between the Domestic credit (% of GDP) in Europe(developing only) and Domestic credit (% of GDP) in Mongolia?
Make the answer very short. 6.94. In the year 2012, what is the difference between the Domestic credit (% of GDP) of Sub-Saharan Africa (developing only) and Domestic credit (% of GDP) of Australia?
Make the answer very short. -68.99. In the year 2012, what is the difference between the Domestic credit (% of GDP) in Sub-Saharan Africa (developing only) and Domestic credit (% of GDP) in Mongolia?
Your answer should be very brief. 9.26. In the year 2012, what is the difference between the Domestic credit (% of GDP) of Australia and Domestic credit (% of GDP) of Mongolia?
Provide a succinct answer. 78.25. In the year 2013, what is the difference between the Domestic credit (% of GDP) of Europe(developing only) and Domestic credit (% of GDP) of Sub-Saharan Africa (developing only)?
Keep it short and to the point. 6.17. In the year 2013, what is the difference between the Domestic credit (% of GDP) in Europe(developing only) and Domestic credit (% of GDP) in Australia?
Ensure brevity in your answer.  -69.72. In the year 2013, what is the difference between the Domestic credit (% of GDP) of Europe(developing only) and Domestic credit (% of GDP) of Mongolia?
Provide a succinct answer. -5.73. In the year 2013, what is the difference between the Domestic credit (% of GDP) of Sub-Saharan Africa (developing only) and Domestic credit (% of GDP) of Australia?
Offer a terse response. -75.89. In the year 2013, what is the difference between the Domestic credit (% of GDP) in Sub-Saharan Africa (developing only) and Domestic credit (% of GDP) in Mongolia?
Ensure brevity in your answer.  -11.89. In the year 2013, what is the difference between the Domestic credit (% of GDP) in Australia and Domestic credit (% of GDP) in Mongolia?
Provide a succinct answer. 63.99. What is the ratio of the Domestic credit (% of GDP) in Europe(developing only) in 2007 to that in 2008?
Provide a succinct answer. 0.84. What is the ratio of the Domestic credit (% of GDP) in Sub-Saharan Africa (developing only) in 2007 to that in 2008?
Give a very brief answer. 1.2. What is the ratio of the Domestic credit (% of GDP) of Australia in 2007 to that in 2008?
Offer a terse response. 0.99. What is the ratio of the Domestic credit (% of GDP) in Mongolia in 2007 to that in 2008?
Provide a short and direct response. 1.04. What is the ratio of the Domestic credit (% of GDP) in Europe(developing only) in 2007 to that in 2009?
Offer a terse response. 0.8. What is the ratio of the Domestic credit (% of GDP) in Sub-Saharan Africa (developing only) in 2007 to that in 2009?
Your response must be concise. 1.06. What is the ratio of the Domestic credit (% of GDP) in Australia in 2007 to that in 2009?
Provide a short and direct response. 0.98. What is the ratio of the Domestic credit (% of GDP) in Mongolia in 2007 to that in 2009?
Make the answer very short. 1.03. What is the ratio of the Domestic credit (% of GDP) of Europe(developing only) in 2007 to that in 2010?
Your answer should be very brief. 0.77. What is the ratio of the Domestic credit (% of GDP) of Sub-Saharan Africa (developing only) in 2007 to that in 2010?
Provide a short and direct response. 1.21. What is the ratio of the Domestic credit (% of GDP) of Australia in 2007 to that in 2010?
Your response must be concise. 0.96. What is the ratio of the Domestic credit (% of GDP) in Mongolia in 2007 to that in 2010?
Give a very brief answer. 1.22. What is the ratio of the Domestic credit (% of GDP) in Europe(developing only) in 2007 to that in 2011?
Keep it short and to the point. 0.74. What is the ratio of the Domestic credit (% of GDP) of Sub-Saharan Africa (developing only) in 2007 to that in 2011?
Offer a terse response. 1.31. What is the ratio of the Domestic credit (% of GDP) of Australia in 2007 to that in 2011?
Make the answer very short. 0.98. What is the ratio of the Domestic credit (% of GDP) in Mongolia in 2007 to that in 2011?
Give a very brief answer. 0.96. What is the ratio of the Domestic credit (% of GDP) of Europe(developing only) in 2007 to that in 2012?
Offer a very short reply. 0.72. What is the ratio of the Domestic credit (% of GDP) in Sub-Saharan Africa (developing only) in 2007 to that in 2012?
Give a very brief answer. 1.35. What is the ratio of the Domestic credit (% of GDP) of Australia in 2007 to that in 2012?
Provide a short and direct response. 0.99. What is the ratio of the Domestic credit (% of GDP) of Mongolia in 2007 to that in 2012?
Provide a succinct answer. 0.95. What is the ratio of the Domestic credit (% of GDP) of Europe(developing only) in 2007 to that in 2013?
Give a very brief answer. 0.65. What is the ratio of the Domestic credit (% of GDP) in Sub-Saharan Africa (developing only) in 2007 to that in 2013?
Give a very brief answer. 1.43. What is the ratio of the Domestic credit (% of GDP) in Australia in 2007 to that in 2013?
Provide a succinct answer. 0.96. What is the ratio of the Domestic credit (% of GDP) in Mongolia in 2007 to that in 2013?
Ensure brevity in your answer.  0.67. What is the ratio of the Domestic credit (% of GDP) in Europe(developing only) in 2008 to that in 2009?
Your answer should be very brief. 0.96. What is the ratio of the Domestic credit (% of GDP) of Sub-Saharan Africa (developing only) in 2008 to that in 2009?
Keep it short and to the point. 0.89. What is the ratio of the Domestic credit (% of GDP) in Mongolia in 2008 to that in 2009?
Your response must be concise. 0.99. What is the ratio of the Domestic credit (% of GDP) of Europe(developing only) in 2008 to that in 2010?
Provide a succinct answer. 0.91. What is the ratio of the Domestic credit (% of GDP) in Sub-Saharan Africa (developing only) in 2008 to that in 2010?
Offer a very short reply. 1.01. What is the ratio of the Domestic credit (% of GDP) in Mongolia in 2008 to that in 2010?
Offer a very short reply. 1.17. What is the ratio of the Domestic credit (% of GDP) of Europe(developing only) in 2008 to that in 2011?
Provide a short and direct response. 0.89. What is the ratio of the Domestic credit (% of GDP) in Sub-Saharan Africa (developing only) in 2008 to that in 2011?
Your answer should be very brief. 1.1. What is the ratio of the Domestic credit (% of GDP) of Australia in 2008 to that in 2011?
Make the answer very short. 0.99. What is the ratio of the Domestic credit (% of GDP) in Mongolia in 2008 to that in 2011?
Your response must be concise. 0.92. What is the ratio of the Domestic credit (% of GDP) in Europe(developing only) in 2008 to that in 2012?
Ensure brevity in your answer.  0.86. What is the ratio of the Domestic credit (% of GDP) of Sub-Saharan Africa (developing only) in 2008 to that in 2012?
Provide a short and direct response. 1.13. What is the ratio of the Domestic credit (% of GDP) in Mongolia in 2008 to that in 2012?
Provide a succinct answer. 0.91. What is the ratio of the Domestic credit (% of GDP) in Europe(developing only) in 2008 to that in 2013?
Make the answer very short. 0.77. What is the ratio of the Domestic credit (% of GDP) of Sub-Saharan Africa (developing only) in 2008 to that in 2013?
Provide a short and direct response. 1.2. What is the ratio of the Domestic credit (% of GDP) of Australia in 2008 to that in 2013?
Give a very brief answer. 0.97. What is the ratio of the Domestic credit (% of GDP) in Mongolia in 2008 to that in 2013?
Provide a short and direct response. 0.65. What is the ratio of the Domestic credit (% of GDP) in Europe(developing only) in 2009 to that in 2010?
Your answer should be very brief. 0.95. What is the ratio of the Domestic credit (% of GDP) of Sub-Saharan Africa (developing only) in 2009 to that in 2010?
Make the answer very short. 1.14. What is the ratio of the Domestic credit (% of GDP) of Australia in 2009 to that in 2010?
Provide a succinct answer. 0.98. What is the ratio of the Domestic credit (% of GDP) of Mongolia in 2009 to that in 2010?
Keep it short and to the point. 1.18. What is the ratio of the Domestic credit (% of GDP) in Europe(developing only) in 2009 to that in 2011?
Provide a succinct answer. 0.93. What is the ratio of the Domestic credit (% of GDP) of Sub-Saharan Africa (developing only) in 2009 to that in 2011?
Your answer should be very brief. 1.23. What is the ratio of the Domestic credit (% of GDP) in Australia in 2009 to that in 2011?
Provide a succinct answer. 1. What is the ratio of the Domestic credit (% of GDP) of Mongolia in 2009 to that in 2011?
Your answer should be compact. 0.93. What is the ratio of the Domestic credit (% of GDP) of Europe(developing only) in 2009 to that in 2012?
Give a very brief answer. 0.9. What is the ratio of the Domestic credit (% of GDP) in Sub-Saharan Africa (developing only) in 2009 to that in 2012?
Your answer should be compact. 1.27. What is the ratio of the Domestic credit (% of GDP) in Australia in 2009 to that in 2012?
Make the answer very short. 1.01. What is the ratio of the Domestic credit (% of GDP) in Mongolia in 2009 to that in 2012?
Keep it short and to the point. 0.92. What is the ratio of the Domestic credit (% of GDP) of Europe(developing only) in 2009 to that in 2013?
Offer a very short reply. 0.81. What is the ratio of the Domestic credit (% of GDP) in Sub-Saharan Africa (developing only) in 2009 to that in 2013?
Give a very brief answer. 1.34. What is the ratio of the Domestic credit (% of GDP) in Australia in 2009 to that in 2013?
Make the answer very short. 0.98. What is the ratio of the Domestic credit (% of GDP) of Mongolia in 2009 to that in 2013?
Give a very brief answer. 0.65. What is the ratio of the Domestic credit (% of GDP) in Europe(developing only) in 2010 to that in 2011?
Offer a terse response. 0.97. What is the ratio of the Domestic credit (% of GDP) of Sub-Saharan Africa (developing only) in 2010 to that in 2011?
Provide a short and direct response. 1.08. What is the ratio of the Domestic credit (% of GDP) in Australia in 2010 to that in 2011?
Offer a very short reply. 1.02. What is the ratio of the Domestic credit (% of GDP) in Mongolia in 2010 to that in 2011?
Keep it short and to the point. 0.79. What is the ratio of the Domestic credit (% of GDP) of Europe(developing only) in 2010 to that in 2012?
Offer a very short reply. 0.94. What is the ratio of the Domestic credit (% of GDP) in Sub-Saharan Africa (developing only) in 2010 to that in 2012?
Keep it short and to the point. 1.11. What is the ratio of the Domestic credit (% of GDP) in Australia in 2010 to that in 2012?
Your response must be concise. 1.03. What is the ratio of the Domestic credit (% of GDP) in Mongolia in 2010 to that in 2012?
Give a very brief answer. 0.78. What is the ratio of the Domestic credit (% of GDP) of Europe(developing only) in 2010 to that in 2013?
Your answer should be compact. 0.85. What is the ratio of the Domestic credit (% of GDP) of Sub-Saharan Africa (developing only) in 2010 to that in 2013?
Make the answer very short. 1.18. What is the ratio of the Domestic credit (% of GDP) of Australia in 2010 to that in 2013?
Make the answer very short. 1. What is the ratio of the Domestic credit (% of GDP) in Mongolia in 2010 to that in 2013?
Provide a short and direct response. 0.55. What is the ratio of the Domestic credit (% of GDP) in Europe(developing only) in 2011 to that in 2012?
Your response must be concise. 0.97. What is the ratio of the Domestic credit (% of GDP) of Sub-Saharan Africa (developing only) in 2011 to that in 2012?
Your answer should be compact. 1.03. What is the ratio of the Domestic credit (% of GDP) of Australia in 2011 to that in 2012?
Your answer should be very brief. 1.01. What is the ratio of the Domestic credit (% of GDP) in Europe(developing only) in 2011 to that in 2013?
Make the answer very short. 0.87. What is the ratio of the Domestic credit (% of GDP) in Sub-Saharan Africa (developing only) in 2011 to that in 2013?
Your answer should be compact. 1.09. What is the ratio of the Domestic credit (% of GDP) of Australia in 2011 to that in 2013?
Offer a very short reply. 0.98. What is the ratio of the Domestic credit (% of GDP) in Mongolia in 2011 to that in 2013?
Offer a terse response. 0.7. What is the ratio of the Domestic credit (% of GDP) of Europe(developing only) in 2012 to that in 2013?
Make the answer very short. 0.9. What is the ratio of the Domestic credit (% of GDP) of Sub-Saharan Africa (developing only) in 2012 to that in 2013?
Your answer should be compact. 1.06. What is the ratio of the Domestic credit (% of GDP) in Australia in 2012 to that in 2013?
Your answer should be compact. 0.97. What is the ratio of the Domestic credit (% of GDP) in Mongolia in 2012 to that in 2013?
Your answer should be compact. 0.71. What is the difference between the highest and the second highest Domestic credit (% of GDP) of Europe(developing only)?
Make the answer very short. 5.38. What is the difference between the highest and the second highest Domestic credit (% of GDP) of Sub-Saharan Africa (developing only)?
Give a very brief answer. 4.31. What is the difference between the highest and the second highest Domestic credit (% of GDP) in Australia?
Ensure brevity in your answer.  0.16. What is the difference between the highest and the second highest Domestic credit (% of GDP) in Mongolia?
Your response must be concise. 18.05. What is the difference between the highest and the lowest Domestic credit (% of GDP) of Europe(developing only)?
Make the answer very short. 19.58. What is the difference between the highest and the lowest Domestic credit (% of GDP) of Sub-Saharan Africa (developing only)?
Your response must be concise. 21.48. What is the difference between the highest and the lowest Domestic credit (% of GDP) in Australia?
Your answer should be very brief. 5.13. What is the difference between the highest and the lowest Domestic credit (% of GDP) in Mongolia?
Ensure brevity in your answer.  27.61. 